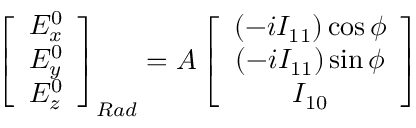Convert formula to latex. <formula><loc_0><loc_0><loc_500><loc_500>\left [ \begin{array} { c } { E _ { x } ^ { 0 } } \\ { E _ { y } ^ { 0 } } \\ { E _ { z } ^ { 0 } } \end{array} \right ] _ { R a d } = A \left [ \begin{array} { c } { \left ( - i I _ { 1 1 } \right ) \cos \phi } \\ { \left ( - i I _ { 1 1 } \right ) \sin \phi } \\ { I _ { 1 0 } } \end{array} \right ]</formula> 